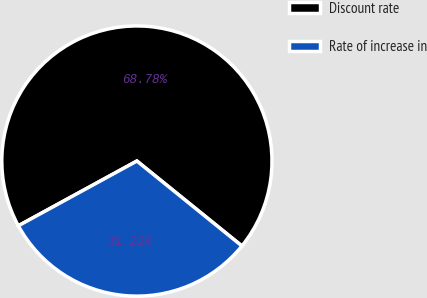Convert chart to OTSL. <chart><loc_0><loc_0><loc_500><loc_500><pie_chart><fcel>Discount rate<fcel>Rate of increase in<nl><fcel>68.78%<fcel>31.22%<nl></chart> 